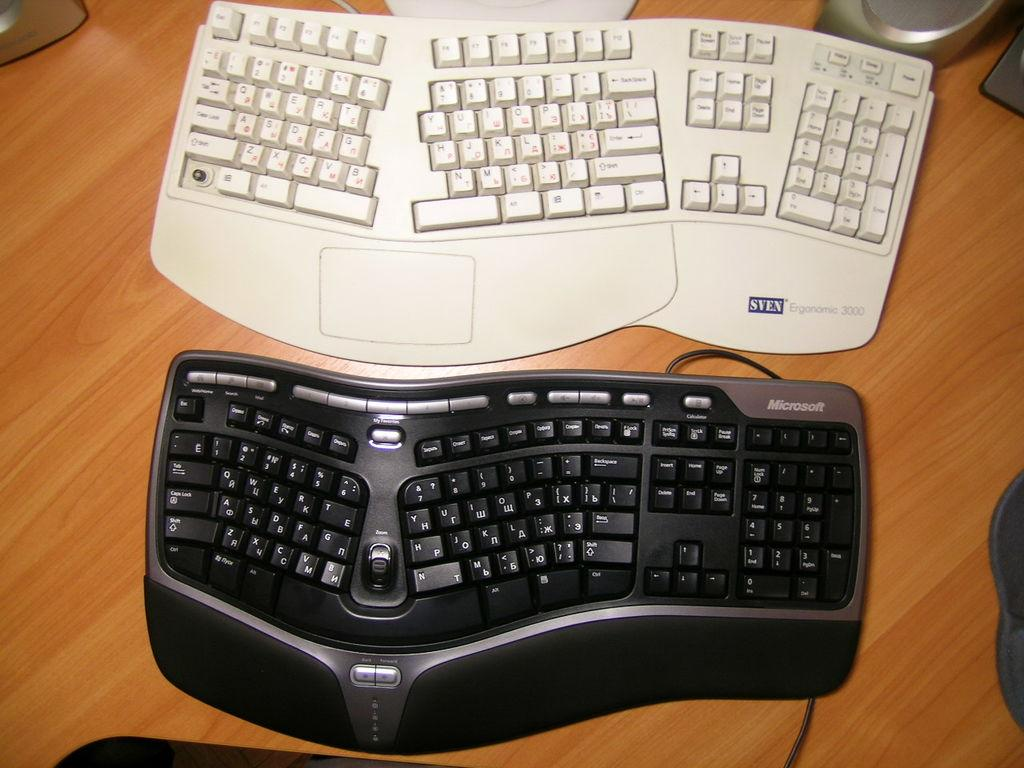<image>
Offer a succinct explanation of the picture presented. A black Microsoft keyboard is next to a white keyboard. 